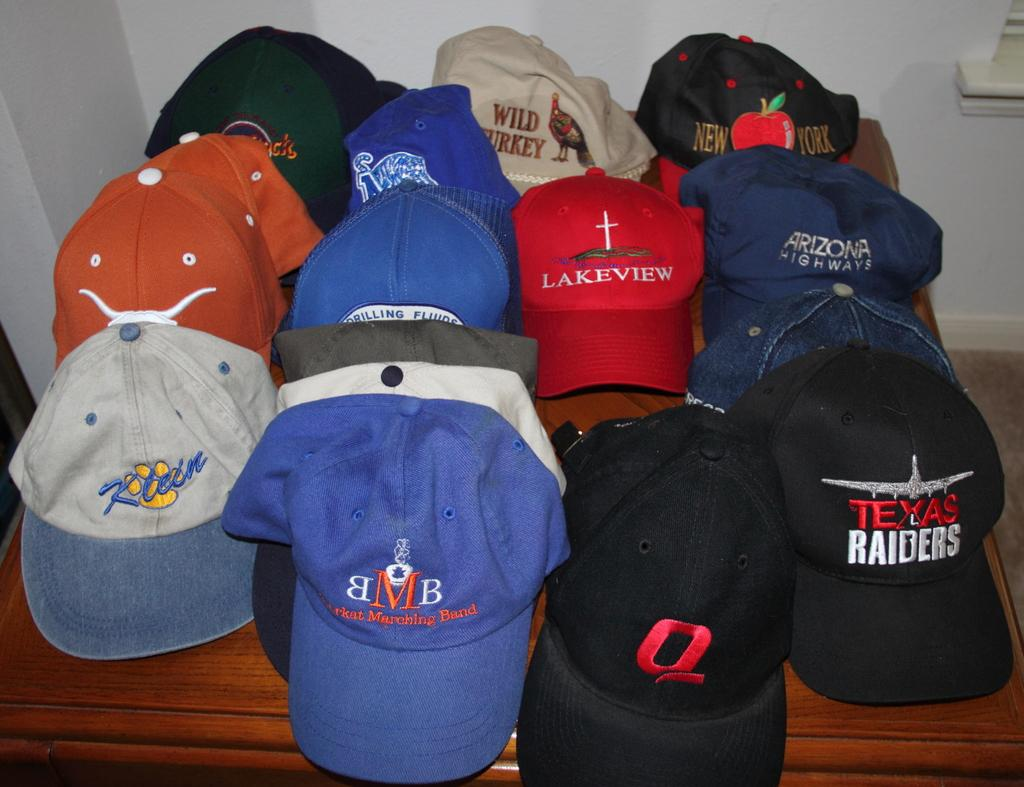<image>
Give a short and clear explanation of the subsequent image. several hats with logos, such as texas raiders and wild turkey 